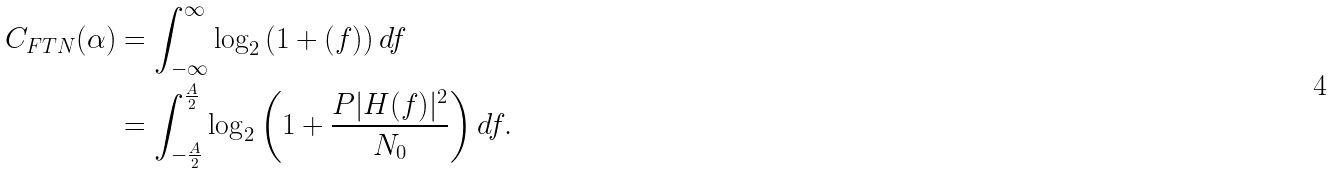Convert formula to latex. <formula><loc_0><loc_0><loc_500><loc_500>C _ { F T N } ( \alpha ) & = \int _ { - \infty } ^ { \infty } \log _ { 2 } \left ( 1 + ( f ) \right ) d f \\ & = \int _ { - \frac { A } { 2 } } ^ { \frac { A } { 2 } } \log _ { 2 } \left ( 1 + \frac { P | H ( f ) | ^ { 2 } } { N _ { 0 } } \right ) d f .</formula> 